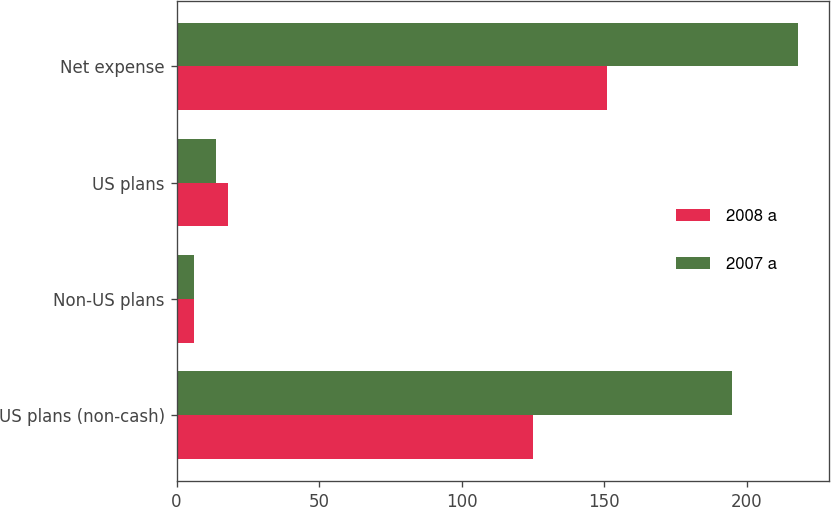Convert chart. <chart><loc_0><loc_0><loc_500><loc_500><stacked_bar_chart><ecel><fcel>US plans (non-cash)<fcel>Non-US plans<fcel>US plans<fcel>Net expense<nl><fcel>2008 a<fcel>125<fcel>6<fcel>18<fcel>151<nl><fcel>2007 a<fcel>195<fcel>6<fcel>14<fcel>218<nl></chart> 